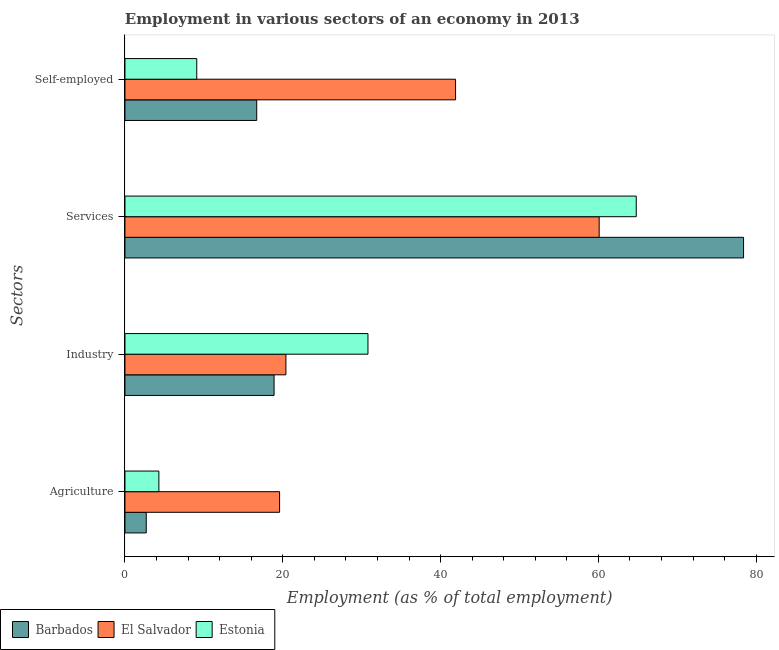How many groups of bars are there?
Your answer should be very brief. 4. Are the number of bars on each tick of the Y-axis equal?
Offer a very short reply. Yes. What is the label of the 1st group of bars from the top?
Offer a terse response. Self-employed. What is the percentage of workers in services in Estonia?
Make the answer very short. 64.8. Across all countries, what is the maximum percentage of workers in services?
Make the answer very short. 78.4. Across all countries, what is the minimum percentage of workers in services?
Your answer should be very brief. 60.1. In which country was the percentage of self employed workers maximum?
Your response must be concise. El Salvador. In which country was the percentage of workers in services minimum?
Your answer should be very brief. El Salvador. What is the total percentage of workers in industry in the graph?
Offer a very short reply. 70.1. What is the difference between the percentage of workers in agriculture in El Salvador and that in Barbados?
Offer a terse response. 16.9. What is the difference between the percentage of workers in services in El Salvador and the percentage of workers in agriculture in Barbados?
Give a very brief answer. 57.4. What is the average percentage of self employed workers per country?
Provide a succinct answer. 22.57. What is the difference between the percentage of workers in industry and percentage of workers in agriculture in Barbados?
Offer a very short reply. 16.2. What is the ratio of the percentage of workers in services in Barbados to that in El Salvador?
Offer a terse response. 1.3. What is the difference between the highest and the second highest percentage of self employed workers?
Keep it short and to the point. 25.2. What is the difference between the highest and the lowest percentage of self employed workers?
Provide a succinct answer. 32.8. Is the sum of the percentage of workers in services in Barbados and Estonia greater than the maximum percentage of self employed workers across all countries?
Ensure brevity in your answer.  Yes. Is it the case that in every country, the sum of the percentage of workers in industry and percentage of workers in services is greater than the sum of percentage of workers in agriculture and percentage of self employed workers?
Your answer should be compact. Yes. What does the 1st bar from the top in Self-employed represents?
Keep it short and to the point. Estonia. What does the 1st bar from the bottom in Self-employed represents?
Your answer should be compact. Barbados. Is it the case that in every country, the sum of the percentage of workers in agriculture and percentage of workers in industry is greater than the percentage of workers in services?
Make the answer very short. No. What is the difference between two consecutive major ticks on the X-axis?
Give a very brief answer. 20. Are the values on the major ticks of X-axis written in scientific E-notation?
Your response must be concise. No. Does the graph contain grids?
Provide a short and direct response. No. What is the title of the graph?
Provide a short and direct response. Employment in various sectors of an economy in 2013. What is the label or title of the X-axis?
Your answer should be very brief. Employment (as % of total employment). What is the label or title of the Y-axis?
Make the answer very short. Sectors. What is the Employment (as % of total employment) of Barbados in Agriculture?
Offer a very short reply. 2.7. What is the Employment (as % of total employment) of El Salvador in Agriculture?
Provide a short and direct response. 19.6. What is the Employment (as % of total employment) of Estonia in Agriculture?
Keep it short and to the point. 4.3. What is the Employment (as % of total employment) in Barbados in Industry?
Ensure brevity in your answer.  18.9. What is the Employment (as % of total employment) of El Salvador in Industry?
Your answer should be compact. 20.4. What is the Employment (as % of total employment) of Estonia in Industry?
Provide a short and direct response. 30.8. What is the Employment (as % of total employment) of Barbados in Services?
Ensure brevity in your answer.  78.4. What is the Employment (as % of total employment) in El Salvador in Services?
Your response must be concise. 60.1. What is the Employment (as % of total employment) in Estonia in Services?
Your response must be concise. 64.8. What is the Employment (as % of total employment) of Barbados in Self-employed?
Ensure brevity in your answer.  16.7. What is the Employment (as % of total employment) in El Salvador in Self-employed?
Give a very brief answer. 41.9. What is the Employment (as % of total employment) of Estonia in Self-employed?
Keep it short and to the point. 9.1. Across all Sectors, what is the maximum Employment (as % of total employment) of Barbados?
Offer a terse response. 78.4. Across all Sectors, what is the maximum Employment (as % of total employment) of El Salvador?
Provide a succinct answer. 60.1. Across all Sectors, what is the maximum Employment (as % of total employment) in Estonia?
Offer a very short reply. 64.8. Across all Sectors, what is the minimum Employment (as % of total employment) of Barbados?
Your response must be concise. 2.7. Across all Sectors, what is the minimum Employment (as % of total employment) of El Salvador?
Your answer should be compact. 19.6. Across all Sectors, what is the minimum Employment (as % of total employment) of Estonia?
Make the answer very short. 4.3. What is the total Employment (as % of total employment) of Barbados in the graph?
Ensure brevity in your answer.  116.7. What is the total Employment (as % of total employment) of El Salvador in the graph?
Ensure brevity in your answer.  142. What is the total Employment (as % of total employment) of Estonia in the graph?
Offer a very short reply. 109. What is the difference between the Employment (as % of total employment) in Barbados in Agriculture and that in Industry?
Your answer should be very brief. -16.2. What is the difference between the Employment (as % of total employment) of El Salvador in Agriculture and that in Industry?
Offer a very short reply. -0.8. What is the difference between the Employment (as % of total employment) of Estonia in Agriculture and that in Industry?
Offer a terse response. -26.5. What is the difference between the Employment (as % of total employment) in Barbados in Agriculture and that in Services?
Provide a succinct answer. -75.7. What is the difference between the Employment (as % of total employment) of El Salvador in Agriculture and that in Services?
Your answer should be very brief. -40.5. What is the difference between the Employment (as % of total employment) in Estonia in Agriculture and that in Services?
Your answer should be very brief. -60.5. What is the difference between the Employment (as % of total employment) in Barbados in Agriculture and that in Self-employed?
Offer a terse response. -14. What is the difference between the Employment (as % of total employment) in El Salvador in Agriculture and that in Self-employed?
Make the answer very short. -22.3. What is the difference between the Employment (as % of total employment) in Barbados in Industry and that in Services?
Offer a very short reply. -59.5. What is the difference between the Employment (as % of total employment) in El Salvador in Industry and that in Services?
Provide a short and direct response. -39.7. What is the difference between the Employment (as % of total employment) in Estonia in Industry and that in Services?
Offer a terse response. -34. What is the difference between the Employment (as % of total employment) in El Salvador in Industry and that in Self-employed?
Provide a succinct answer. -21.5. What is the difference between the Employment (as % of total employment) in Estonia in Industry and that in Self-employed?
Your response must be concise. 21.7. What is the difference between the Employment (as % of total employment) of Barbados in Services and that in Self-employed?
Make the answer very short. 61.7. What is the difference between the Employment (as % of total employment) of Estonia in Services and that in Self-employed?
Ensure brevity in your answer.  55.7. What is the difference between the Employment (as % of total employment) in Barbados in Agriculture and the Employment (as % of total employment) in El Salvador in Industry?
Provide a succinct answer. -17.7. What is the difference between the Employment (as % of total employment) of Barbados in Agriculture and the Employment (as % of total employment) of Estonia in Industry?
Your response must be concise. -28.1. What is the difference between the Employment (as % of total employment) in Barbados in Agriculture and the Employment (as % of total employment) in El Salvador in Services?
Your response must be concise. -57.4. What is the difference between the Employment (as % of total employment) of Barbados in Agriculture and the Employment (as % of total employment) of Estonia in Services?
Give a very brief answer. -62.1. What is the difference between the Employment (as % of total employment) in El Salvador in Agriculture and the Employment (as % of total employment) in Estonia in Services?
Provide a succinct answer. -45.2. What is the difference between the Employment (as % of total employment) of Barbados in Agriculture and the Employment (as % of total employment) of El Salvador in Self-employed?
Offer a terse response. -39.2. What is the difference between the Employment (as % of total employment) of Barbados in Agriculture and the Employment (as % of total employment) of Estonia in Self-employed?
Keep it short and to the point. -6.4. What is the difference between the Employment (as % of total employment) of El Salvador in Agriculture and the Employment (as % of total employment) of Estonia in Self-employed?
Your answer should be compact. 10.5. What is the difference between the Employment (as % of total employment) in Barbados in Industry and the Employment (as % of total employment) in El Salvador in Services?
Your answer should be very brief. -41.2. What is the difference between the Employment (as % of total employment) of Barbados in Industry and the Employment (as % of total employment) of Estonia in Services?
Your response must be concise. -45.9. What is the difference between the Employment (as % of total employment) in El Salvador in Industry and the Employment (as % of total employment) in Estonia in Services?
Provide a short and direct response. -44.4. What is the difference between the Employment (as % of total employment) in Barbados in Industry and the Employment (as % of total employment) in El Salvador in Self-employed?
Offer a terse response. -23. What is the difference between the Employment (as % of total employment) in El Salvador in Industry and the Employment (as % of total employment) in Estonia in Self-employed?
Ensure brevity in your answer.  11.3. What is the difference between the Employment (as % of total employment) in Barbados in Services and the Employment (as % of total employment) in El Salvador in Self-employed?
Your answer should be compact. 36.5. What is the difference between the Employment (as % of total employment) of Barbados in Services and the Employment (as % of total employment) of Estonia in Self-employed?
Provide a succinct answer. 69.3. What is the difference between the Employment (as % of total employment) of El Salvador in Services and the Employment (as % of total employment) of Estonia in Self-employed?
Offer a very short reply. 51. What is the average Employment (as % of total employment) in Barbados per Sectors?
Your response must be concise. 29.18. What is the average Employment (as % of total employment) of El Salvador per Sectors?
Provide a succinct answer. 35.5. What is the average Employment (as % of total employment) of Estonia per Sectors?
Keep it short and to the point. 27.25. What is the difference between the Employment (as % of total employment) in Barbados and Employment (as % of total employment) in El Salvador in Agriculture?
Your response must be concise. -16.9. What is the difference between the Employment (as % of total employment) in Barbados and Employment (as % of total employment) in El Salvador in Industry?
Your answer should be compact. -1.5. What is the difference between the Employment (as % of total employment) in El Salvador and Employment (as % of total employment) in Estonia in Industry?
Provide a short and direct response. -10.4. What is the difference between the Employment (as % of total employment) of El Salvador and Employment (as % of total employment) of Estonia in Services?
Provide a succinct answer. -4.7. What is the difference between the Employment (as % of total employment) of Barbados and Employment (as % of total employment) of El Salvador in Self-employed?
Keep it short and to the point. -25.2. What is the difference between the Employment (as % of total employment) in Barbados and Employment (as % of total employment) in Estonia in Self-employed?
Your response must be concise. 7.6. What is the difference between the Employment (as % of total employment) in El Salvador and Employment (as % of total employment) in Estonia in Self-employed?
Your response must be concise. 32.8. What is the ratio of the Employment (as % of total employment) of Barbados in Agriculture to that in Industry?
Your answer should be very brief. 0.14. What is the ratio of the Employment (as % of total employment) in El Salvador in Agriculture to that in Industry?
Make the answer very short. 0.96. What is the ratio of the Employment (as % of total employment) in Estonia in Agriculture to that in Industry?
Give a very brief answer. 0.14. What is the ratio of the Employment (as % of total employment) of Barbados in Agriculture to that in Services?
Make the answer very short. 0.03. What is the ratio of the Employment (as % of total employment) of El Salvador in Agriculture to that in Services?
Your response must be concise. 0.33. What is the ratio of the Employment (as % of total employment) in Estonia in Agriculture to that in Services?
Offer a terse response. 0.07. What is the ratio of the Employment (as % of total employment) in Barbados in Agriculture to that in Self-employed?
Your answer should be very brief. 0.16. What is the ratio of the Employment (as % of total employment) in El Salvador in Agriculture to that in Self-employed?
Offer a very short reply. 0.47. What is the ratio of the Employment (as % of total employment) in Estonia in Agriculture to that in Self-employed?
Offer a very short reply. 0.47. What is the ratio of the Employment (as % of total employment) in Barbados in Industry to that in Services?
Keep it short and to the point. 0.24. What is the ratio of the Employment (as % of total employment) of El Salvador in Industry to that in Services?
Make the answer very short. 0.34. What is the ratio of the Employment (as % of total employment) of Estonia in Industry to that in Services?
Your answer should be compact. 0.48. What is the ratio of the Employment (as % of total employment) of Barbados in Industry to that in Self-employed?
Your answer should be very brief. 1.13. What is the ratio of the Employment (as % of total employment) in El Salvador in Industry to that in Self-employed?
Ensure brevity in your answer.  0.49. What is the ratio of the Employment (as % of total employment) in Estonia in Industry to that in Self-employed?
Give a very brief answer. 3.38. What is the ratio of the Employment (as % of total employment) in Barbados in Services to that in Self-employed?
Offer a terse response. 4.69. What is the ratio of the Employment (as % of total employment) of El Salvador in Services to that in Self-employed?
Make the answer very short. 1.43. What is the ratio of the Employment (as % of total employment) in Estonia in Services to that in Self-employed?
Offer a terse response. 7.12. What is the difference between the highest and the second highest Employment (as % of total employment) in Barbados?
Your answer should be compact. 59.5. What is the difference between the highest and the lowest Employment (as % of total employment) of Barbados?
Your answer should be compact. 75.7. What is the difference between the highest and the lowest Employment (as % of total employment) of El Salvador?
Offer a very short reply. 40.5. What is the difference between the highest and the lowest Employment (as % of total employment) in Estonia?
Ensure brevity in your answer.  60.5. 